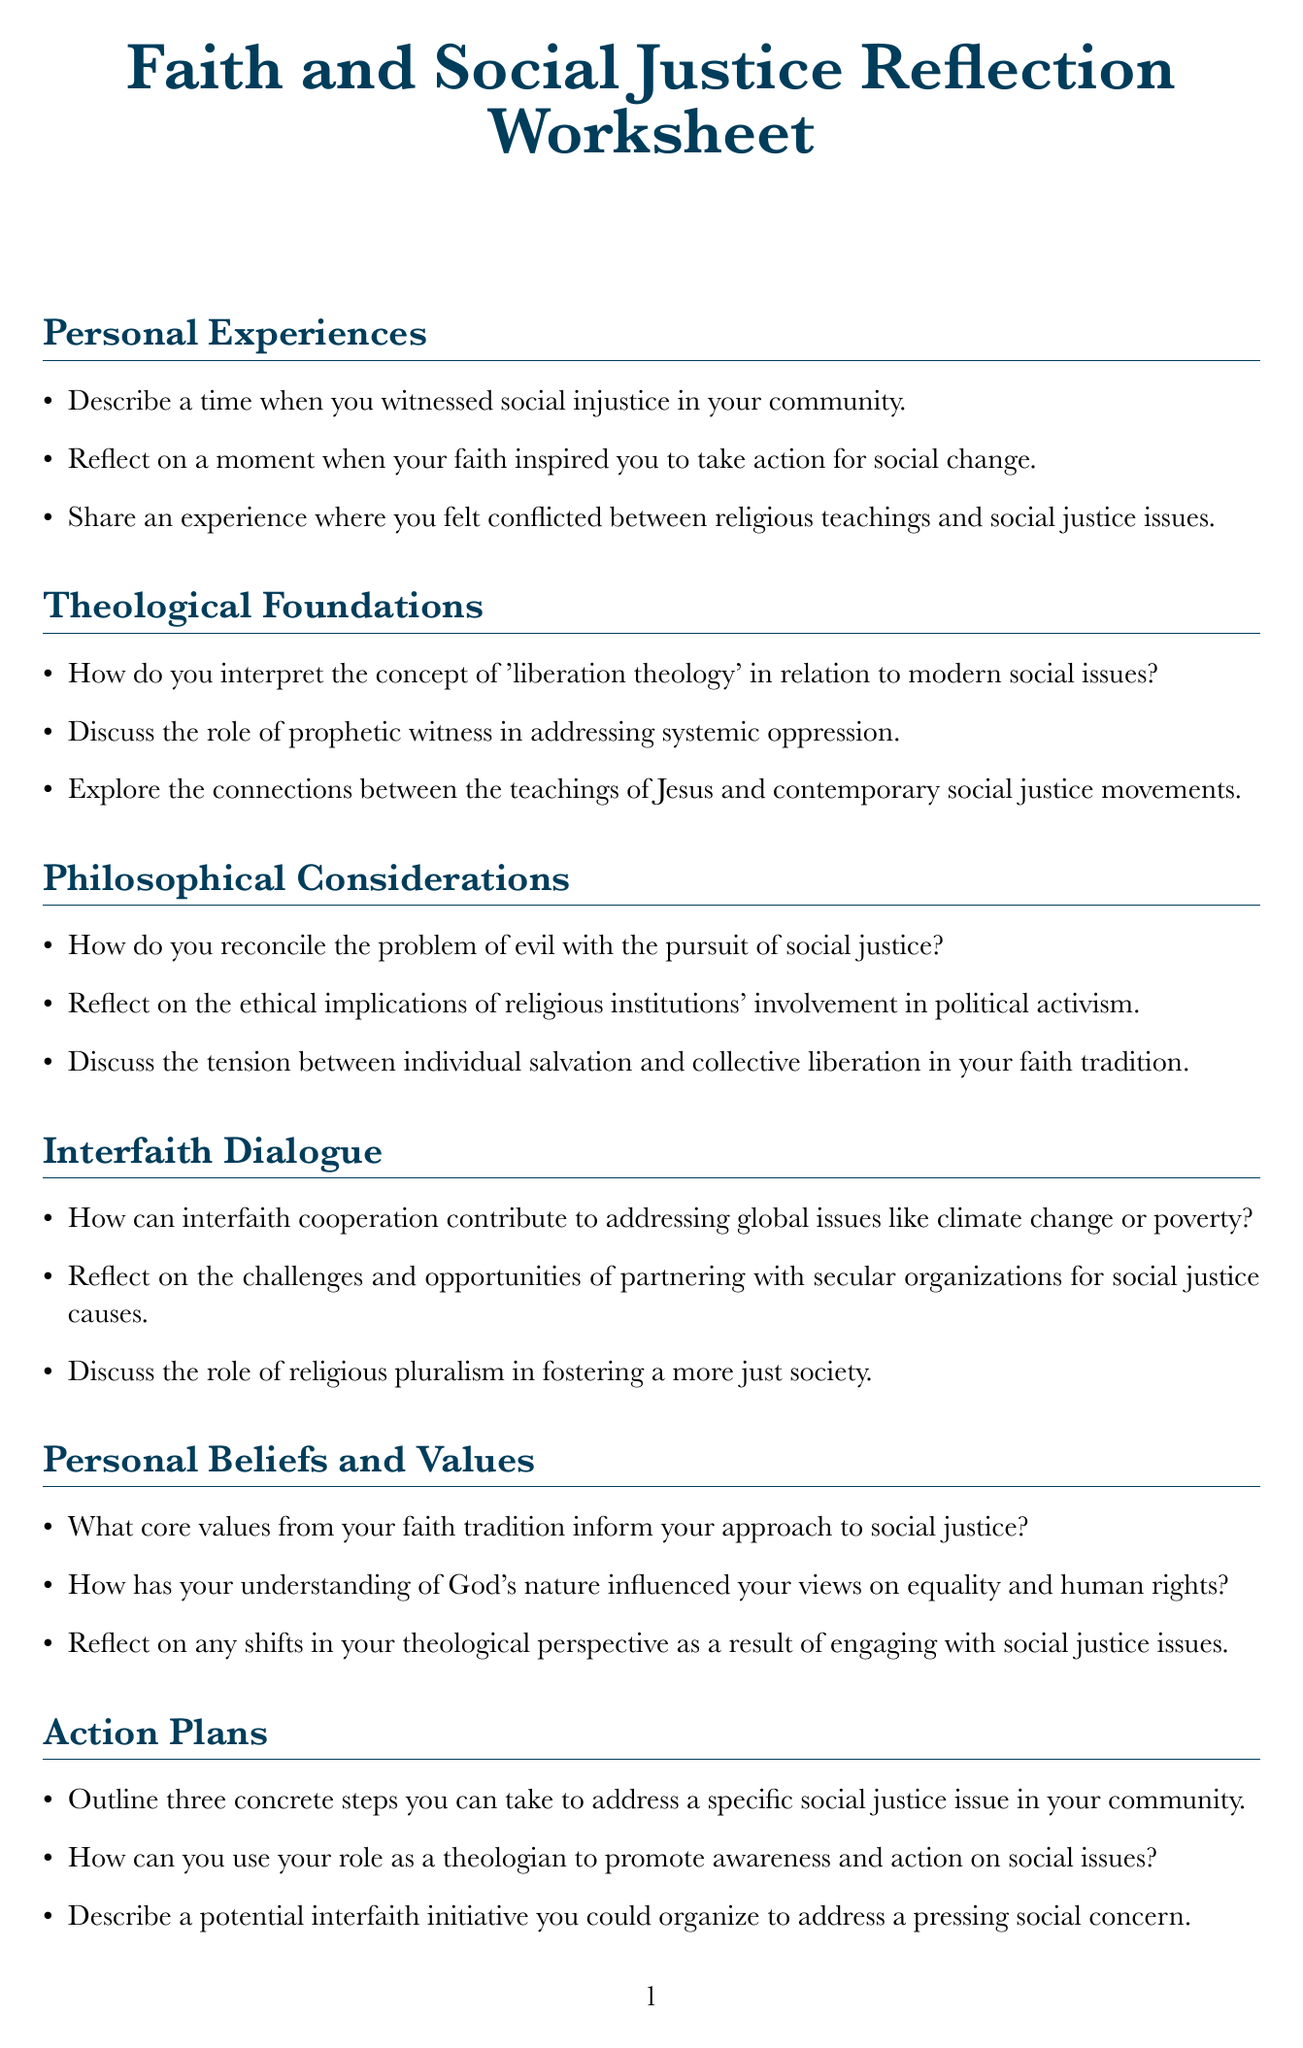What is the title of the worksheet? The title is explicitly stated at the beginning of the document.
Answer: Faith and Social Justice Reflection Worksheet How many sections are there in the document? The document lists all the sections under which prompts are organized.
Answer: 7 What is one prompt from the "Personal Experiences" section? The prompts are listed in the section and can be directly quoted.
Answer: Describe a time when you witnessed social injustice in your community What does the "Action Plans" section ask for? This section specifies that it seeks concrete steps, awareness promotion, and organizing initiatives.
Answer: Three concrete steps What theme does the "Theological Foundations" section focus on? The section title indicates its focus on the relationship between theology and social issues.
Answer: Theological Foundations Which section addresses interfaith cooperation? This can be inferred from the section title indicating the theme of interfaith dialogue.
Answer: Interfaith Dialogue What is one challenge discussed in the "Challenges and Growth" section? This section lists specific challenges encountered in the process of engaging with social issues.
Answer: Resistance encountered when discussing social justice Name a category of questions explored in the document. The document has distinct sections that categorize the prompts for reflection and discussion.
Answer: Philosophical Considerations Who is the intended audience for this worksheet? The context and language used in the document suggest it is aimed at individuals reflecting on their faith and social justice.
Answer: Theologians and individuals of faith 